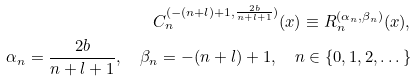<formula> <loc_0><loc_0><loc_500><loc_500>C _ { n } ^ { ( - ( n + l ) + 1 , \frac { 2 b } { n + l + 1 } ) } ( x ) \equiv R _ { n } ^ { ( \alpha _ { n } , \beta _ { n } ) } ( x ) , & \\ \alpha _ { n } = \frac { 2 b } { n + l + 1 } , \quad \beta _ { n } = - ( n + l ) + 1 , \quad n \in \{ 0 , 1 , 2 , \dots \} &</formula> 